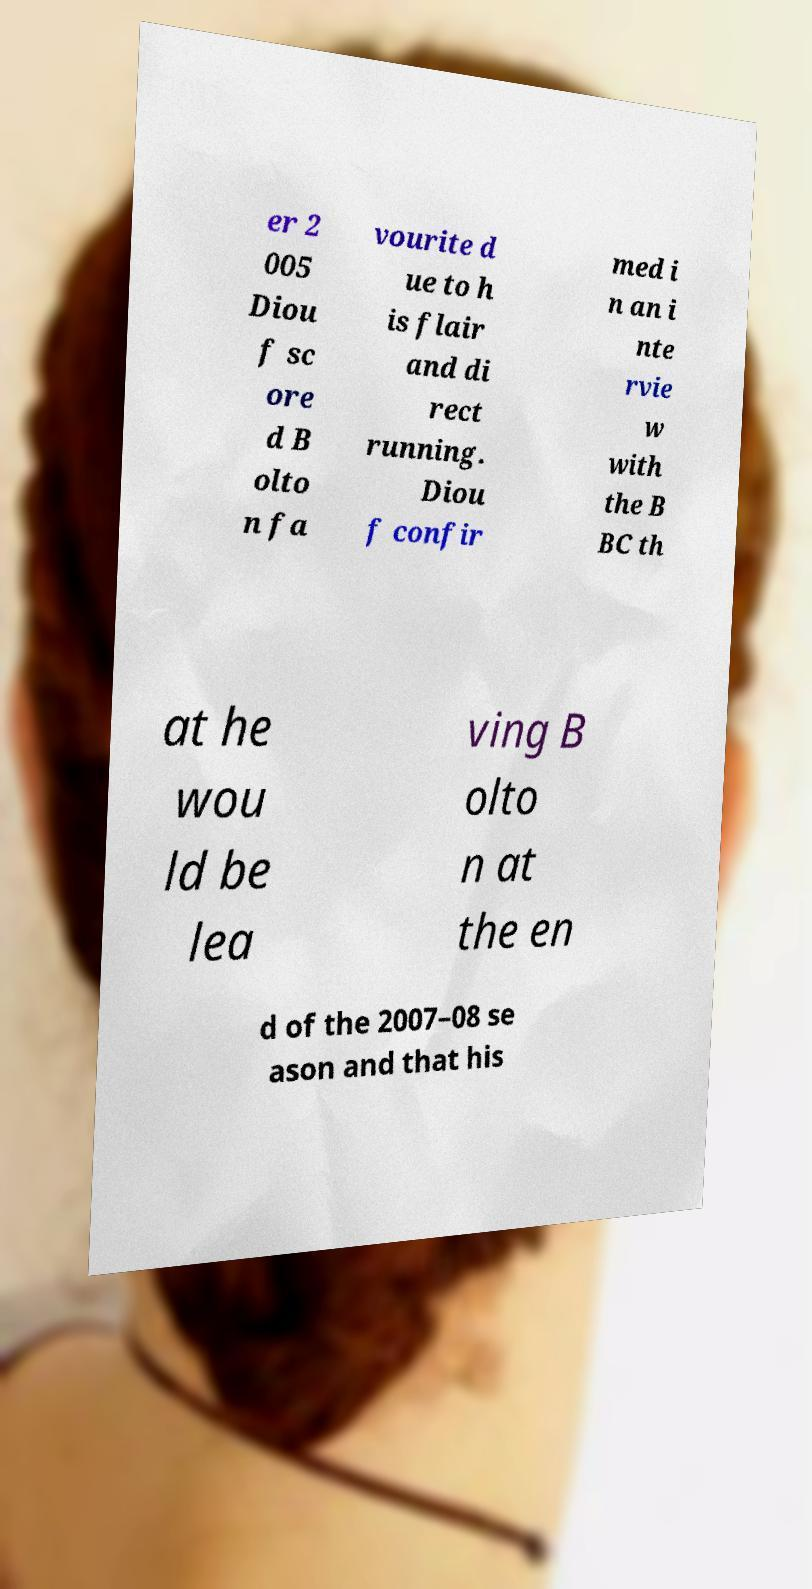What messages or text are displayed in this image? I need them in a readable, typed format. er 2 005 Diou f sc ore d B olto n fa vourite d ue to h is flair and di rect running. Diou f confir med i n an i nte rvie w with the B BC th at he wou ld be lea ving B olto n at the en d of the 2007–08 se ason and that his 